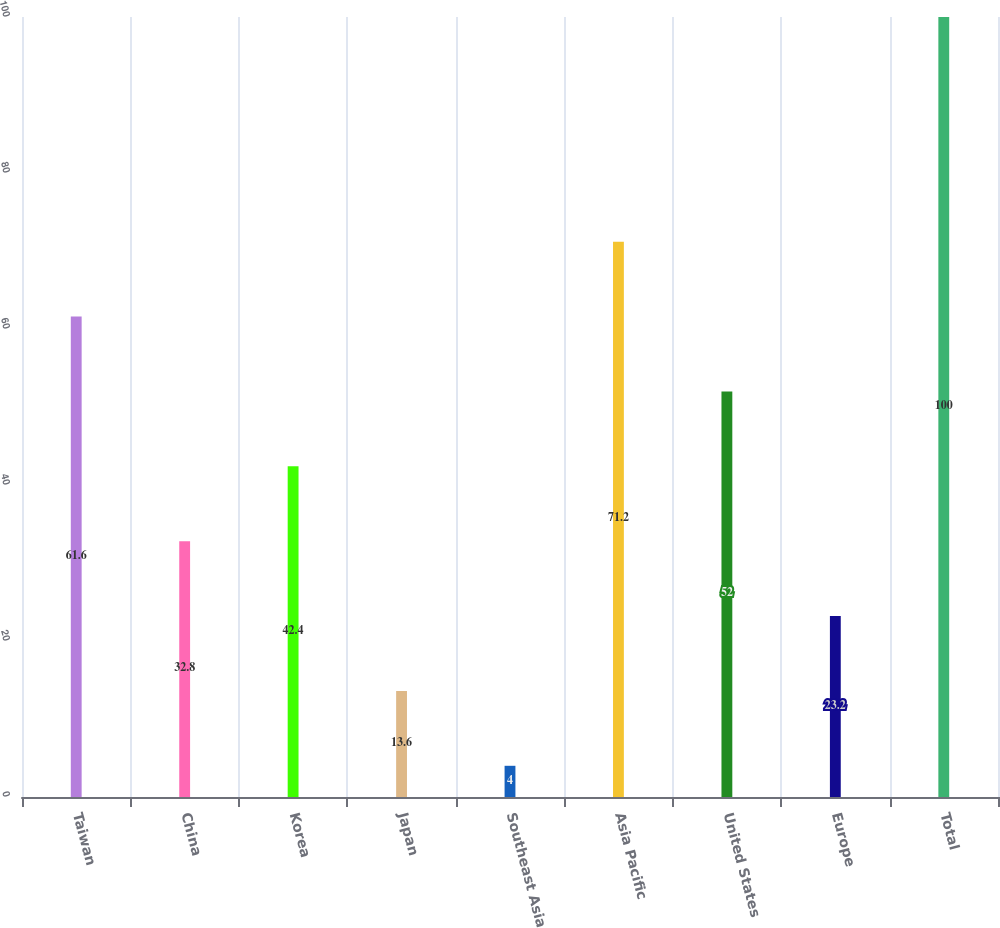Convert chart. <chart><loc_0><loc_0><loc_500><loc_500><bar_chart><fcel>Taiwan<fcel>China<fcel>Korea<fcel>Japan<fcel>Southeast Asia<fcel>Asia Pacific<fcel>United States<fcel>Europe<fcel>Total<nl><fcel>61.6<fcel>32.8<fcel>42.4<fcel>13.6<fcel>4<fcel>71.2<fcel>52<fcel>23.2<fcel>100<nl></chart> 